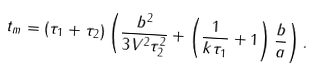Convert formula to latex. <formula><loc_0><loc_0><loc_500><loc_500>t _ { m } = ( \tau _ { 1 } + \tau _ { 2 } ) \left ( \frac { b ^ { 2 } } { 3 V ^ { 2 } \tau _ { 2 } ^ { 2 } } + \left ( \frac { 1 } { k \tau _ { 1 } } + 1 \right ) \frac { b } { a } \right ) .</formula> 